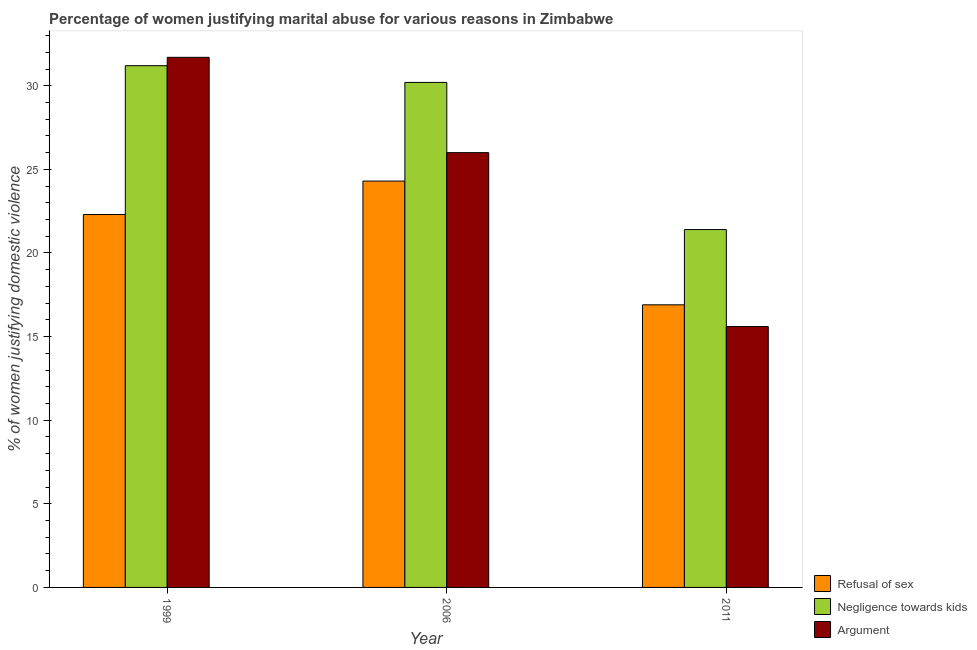How many different coloured bars are there?
Provide a succinct answer. 3. How many bars are there on the 1st tick from the right?
Provide a succinct answer. 3. What is the label of the 1st group of bars from the left?
Offer a very short reply. 1999. What is the percentage of women justifying domestic violence due to negligence towards kids in 2011?
Keep it short and to the point. 21.4. Across all years, what is the maximum percentage of women justifying domestic violence due to refusal of sex?
Your answer should be compact. 24.3. Across all years, what is the minimum percentage of women justifying domestic violence due to negligence towards kids?
Provide a succinct answer. 21.4. In which year was the percentage of women justifying domestic violence due to refusal of sex minimum?
Provide a succinct answer. 2011. What is the total percentage of women justifying domestic violence due to negligence towards kids in the graph?
Give a very brief answer. 82.8. What is the difference between the percentage of women justifying domestic violence due to refusal of sex in 1999 and the percentage of women justifying domestic violence due to negligence towards kids in 2011?
Your answer should be compact. 5.4. What is the average percentage of women justifying domestic violence due to arguments per year?
Offer a terse response. 24.43. In how many years, is the percentage of women justifying domestic violence due to arguments greater than 17 %?
Ensure brevity in your answer.  2. What is the ratio of the percentage of women justifying domestic violence due to negligence towards kids in 2006 to that in 2011?
Ensure brevity in your answer.  1.41. What is the difference between the highest and the second highest percentage of women justifying domestic violence due to arguments?
Provide a short and direct response. 5.7. What is the difference between the highest and the lowest percentage of women justifying domestic violence due to refusal of sex?
Make the answer very short. 7.4. In how many years, is the percentage of women justifying domestic violence due to negligence towards kids greater than the average percentage of women justifying domestic violence due to negligence towards kids taken over all years?
Your answer should be compact. 2. Is the sum of the percentage of women justifying domestic violence due to negligence towards kids in 1999 and 2006 greater than the maximum percentage of women justifying domestic violence due to arguments across all years?
Offer a very short reply. Yes. What does the 2nd bar from the left in 2006 represents?
Your answer should be very brief. Negligence towards kids. What does the 2nd bar from the right in 2011 represents?
Give a very brief answer. Negligence towards kids. Is it the case that in every year, the sum of the percentage of women justifying domestic violence due to refusal of sex and percentage of women justifying domestic violence due to negligence towards kids is greater than the percentage of women justifying domestic violence due to arguments?
Your response must be concise. Yes. How many bars are there?
Your answer should be very brief. 9. Are all the bars in the graph horizontal?
Your response must be concise. No. How many years are there in the graph?
Offer a very short reply. 3. Does the graph contain any zero values?
Provide a short and direct response. No. Does the graph contain grids?
Your response must be concise. No. Where does the legend appear in the graph?
Provide a succinct answer. Bottom right. How are the legend labels stacked?
Your answer should be compact. Vertical. What is the title of the graph?
Give a very brief answer. Percentage of women justifying marital abuse for various reasons in Zimbabwe. What is the label or title of the Y-axis?
Provide a succinct answer. % of women justifying domestic violence. What is the % of women justifying domestic violence of Refusal of sex in 1999?
Ensure brevity in your answer.  22.3. What is the % of women justifying domestic violence of Negligence towards kids in 1999?
Your response must be concise. 31.2. What is the % of women justifying domestic violence in Argument in 1999?
Offer a terse response. 31.7. What is the % of women justifying domestic violence in Refusal of sex in 2006?
Offer a very short reply. 24.3. What is the % of women justifying domestic violence in Negligence towards kids in 2006?
Your response must be concise. 30.2. What is the % of women justifying domestic violence in Negligence towards kids in 2011?
Give a very brief answer. 21.4. Across all years, what is the maximum % of women justifying domestic violence in Refusal of sex?
Offer a terse response. 24.3. Across all years, what is the maximum % of women justifying domestic violence of Negligence towards kids?
Make the answer very short. 31.2. Across all years, what is the maximum % of women justifying domestic violence of Argument?
Ensure brevity in your answer.  31.7. Across all years, what is the minimum % of women justifying domestic violence in Refusal of sex?
Your answer should be very brief. 16.9. Across all years, what is the minimum % of women justifying domestic violence of Negligence towards kids?
Your answer should be very brief. 21.4. Across all years, what is the minimum % of women justifying domestic violence in Argument?
Your response must be concise. 15.6. What is the total % of women justifying domestic violence of Refusal of sex in the graph?
Provide a succinct answer. 63.5. What is the total % of women justifying domestic violence of Negligence towards kids in the graph?
Offer a very short reply. 82.8. What is the total % of women justifying domestic violence of Argument in the graph?
Make the answer very short. 73.3. What is the difference between the % of women justifying domestic violence of Negligence towards kids in 1999 and that in 2006?
Your answer should be very brief. 1. What is the difference between the % of women justifying domestic violence in Argument in 1999 and that in 2006?
Your answer should be very brief. 5.7. What is the difference between the % of women justifying domestic violence of Refusal of sex in 1999 and that in 2011?
Give a very brief answer. 5.4. What is the difference between the % of women justifying domestic violence of Argument in 1999 and that in 2011?
Provide a short and direct response. 16.1. What is the difference between the % of women justifying domestic violence in Refusal of sex in 1999 and the % of women justifying domestic violence in Negligence towards kids in 2006?
Make the answer very short. -7.9. What is the difference between the % of women justifying domestic violence in Refusal of sex in 1999 and the % of women justifying domestic violence in Argument in 2006?
Make the answer very short. -3.7. What is the difference between the % of women justifying domestic violence of Negligence towards kids in 1999 and the % of women justifying domestic violence of Argument in 2011?
Offer a terse response. 15.6. What is the difference between the % of women justifying domestic violence of Negligence towards kids in 2006 and the % of women justifying domestic violence of Argument in 2011?
Make the answer very short. 14.6. What is the average % of women justifying domestic violence of Refusal of sex per year?
Ensure brevity in your answer.  21.17. What is the average % of women justifying domestic violence of Negligence towards kids per year?
Offer a very short reply. 27.6. What is the average % of women justifying domestic violence of Argument per year?
Offer a very short reply. 24.43. In the year 1999, what is the difference between the % of women justifying domestic violence in Refusal of sex and % of women justifying domestic violence in Negligence towards kids?
Your answer should be very brief. -8.9. In the year 2006, what is the difference between the % of women justifying domestic violence of Refusal of sex and % of women justifying domestic violence of Negligence towards kids?
Ensure brevity in your answer.  -5.9. In the year 2006, what is the difference between the % of women justifying domestic violence in Refusal of sex and % of women justifying domestic violence in Argument?
Give a very brief answer. -1.7. In the year 2006, what is the difference between the % of women justifying domestic violence in Negligence towards kids and % of women justifying domestic violence in Argument?
Provide a short and direct response. 4.2. In the year 2011, what is the difference between the % of women justifying domestic violence in Refusal of sex and % of women justifying domestic violence in Negligence towards kids?
Your answer should be compact. -4.5. In the year 2011, what is the difference between the % of women justifying domestic violence of Negligence towards kids and % of women justifying domestic violence of Argument?
Keep it short and to the point. 5.8. What is the ratio of the % of women justifying domestic violence in Refusal of sex in 1999 to that in 2006?
Give a very brief answer. 0.92. What is the ratio of the % of women justifying domestic violence of Negligence towards kids in 1999 to that in 2006?
Provide a short and direct response. 1.03. What is the ratio of the % of women justifying domestic violence of Argument in 1999 to that in 2006?
Your response must be concise. 1.22. What is the ratio of the % of women justifying domestic violence of Refusal of sex in 1999 to that in 2011?
Make the answer very short. 1.32. What is the ratio of the % of women justifying domestic violence of Negligence towards kids in 1999 to that in 2011?
Your response must be concise. 1.46. What is the ratio of the % of women justifying domestic violence in Argument in 1999 to that in 2011?
Your answer should be compact. 2.03. What is the ratio of the % of women justifying domestic violence in Refusal of sex in 2006 to that in 2011?
Make the answer very short. 1.44. What is the ratio of the % of women justifying domestic violence of Negligence towards kids in 2006 to that in 2011?
Ensure brevity in your answer.  1.41. What is the difference between the highest and the second highest % of women justifying domestic violence of Refusal of sex?
Make the answer very short. 2. What is the difference between the highest and the second highest % of women justifying domestic violence in Negligence towards kids?
Provide a succinct answer. 1. 